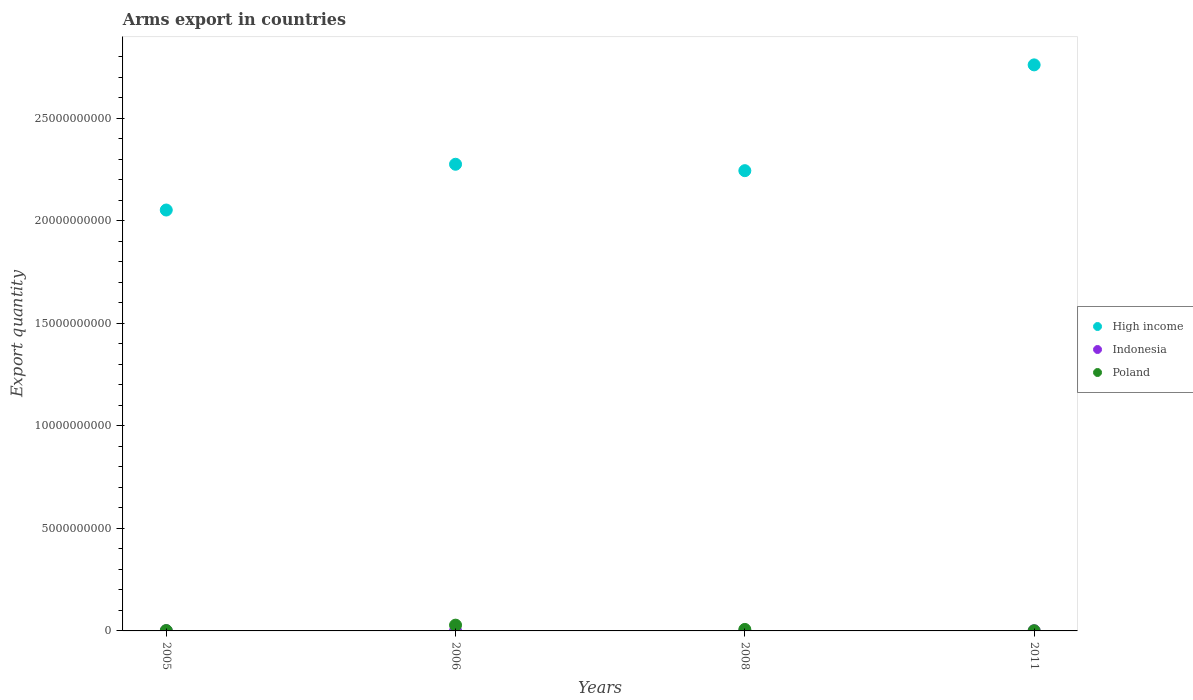Is the number of dotlines equal to the number of legend labels?
Keep it short and to the point. Yes. What is the total arms export in Poland in 2008?
Your response must be concise. 7.30e+07. Across all years, what is the maximum total arms export in Poland?
Offer a very short reply. 2.82e+08. In which year was the total arms export in High income maximum?
Make the answer very short. 2011. What is the total total arms export in Poland in the graph?
Keep it short and to the point. 3.81e+08. What is the difference between the total arms export in Poland in 2005 and that in 2006?
Your response must be concise. -2.64e+08. What is the difference between the total arms export in High income in 2006 and the total arms export in Poland in 2005?
Provide a short and direct response. 2.27e+1. What is the average total arms export in High income per year?
Provide a short and direct response. 2.33e+1. In the year 2006, what is the difference between the total arms export in High income and total arms export in Indonesia?
Offer a terse response. 2.28e+1. In how many years, is the total arms export in High income greater than 8000000000?
Offer a terse response. 4. What is the ratio of the total arms export in High income in 2008 to that in 2011?
Keep it short and to the point. 0.81. Is the total arms export in Indonesia in 2005 less than that in 2011?
Give a very brief answer. No. Is the difference between the total arms export in High income in 2008 and 2011 greater than the difference between the total arms export in Indonesia in 2008 and 2011?
Your answer should be compact. No. What is the difference between the highest and the second highest total arms export in Indonesia?
Provide a succinct answer. 0. What is the difference between the highest and the lowest total arms export in High income?
Your answer should be compact. 7.08e+09. In how many years, is the total arms export in High income greater than the average total arms export in High income taken over all years?
Offer a very short reply. 1. Is the sum of the total arms export in High income in 2005 and 2011 greater than the maximum total arms export in Poland across all years?
Offer a very short reply. Yes. How many years are there in the graph?
Keep it short and to the point. 4. Does the graph contain any zero values?
Ensure brevity in your answer.  No. Where does the legend appear in the graph?
Provide a short and direct response. Center right. How many legend labels are there?
Provide a short and direct response. 3. How are the legend labels stacked?
Your response must be concise. Vertical. What is the title of the graph?
Offer a terse response. Arms export in countries. What is the label or title of the Y-axis?
Offer a very short reply. Export quantity. What is the Export quantity of High income in 2005?
Keep it short and to the point. 2.05e+1. What is the Export quantity of Poland in 2005?
Your answer should be very brief. 1.80e+07. What is the Export quantity in High income in 2006?
Provide a succinct answer. 2.28e+1. What is the Export quantity in Indonesia in 2006?
Make the answer very short. 8.00e+06. What is the Export quantity of Poland in 2006?
Keep it short and to the point. 2.82e+08. What is the Export quantity of High income in 2008?
Your response must be concise. 2.25e+1. What is the Export quantity of Poland in 2008?
Give a very brief answer. 7.30e+07. What is the Export quantity of High income in 2011?
Your answer should be compact. 2.76e+1. Across all years, what is the maximum Export quantity in High income?
Offer a very short reply. 2.76e+1. Across all years, what is the maximum Export quantity in Poland?
Offer a terse response. 2.82e+08. Across all years, what is the minimum Export quantity in High income?
Keep it short and to the point. 2.05e+1. What is the total Export quantity of High income in the graph?
Provide a succinct answer. 9.34e+1. What is the total Export quantity in Indonesia in the graph?
Offer a very short reply. 2.50e+07. What is the total Export quantity of Poland in the graph?
Your response must be concise. 3.81e+08. What is the difference between the Export quantity in High income in 2005 and that in 2006?
Make the answer very short. -2.23e+09. What is the difference between the Export quantity in Poland in 2005 and that in 2006?
Keep it short and to the point. -2.64e+08. What is the difference between the Export quantity in High income in 2005 and that in 2008?
Offer a terse response. -1.92e+09. What is the difference between the Export quantity in Indonesia in 2005 and that in 2008?
Keep it short and to the point. 7.00e+06. What is the difference between the Export quantity of Poland in 2005 and that in 2008?
Give a very brief answer. -5.50e+07. What is the difference between the Export quantity of High income in 2005 and that in 2011?
Your response must be concise. -7.08e+09. What is the difference between the Export quantity in High income in 2006 and that in 2008?
Ensure brevity in your answer.  3.13e+08. What is the difference between the Export quantity of Indonesia in 2006 and that in 2008?
Your response must be concise. 7.00e+06. What is the difference between the Export quantity in Poland in 2006 and that in 2008?
Your response must be concise. 2.09e+08. What is the difference between the Export quantity in High income in 2006 and that in 2011?
Offer a very short reply. -4.85e+09. What is the difference between the Export quantity in Poland in 2006 and that in 2011?
Offer a terse response. 2.74e+08. What is the difference between the Export quantity of High income in 2008 and that in 2011?
Your answer should be compact. -5.16e+09. What is the difference between the Export quantity in Indonesia in 2008 and that in 2011?
Offer a very short reply. -7.00e+06. What is the difference between the Export quantity in Poland in 2008 and that in 2011?
Provide a short and direct response. 6.50e+07. What is the difference between the Export quantity in High income in 2005 and the Export quantity in Indonesia in 2006?
Provide a short and direct response. 2.05e+1. What is the difference between the Export quantity of High income in 2005 and the Export quantity of Poland in 2006?
Offer a very short reply. 2.03e+1. What is the difference between the Export quantity in Indonesia in 2005 and the Export quantity in Poland in 2006?
Keep it short and to the point. -2.74e+08. What is the difference between the Export quantity of High income in 2005 and the Export quantity of Indonesia in 2008?
Ensure brevity in your answer.  2.05e+1. What is the difference between the Export quantity in High income in 2005 and the Export quantity in Poland in 2008?
Give a very brief answer. 2.05e+1. What is the difference between the Export quantity of Indonesia in 2005 and the Export quantity of Poland in 2008?
Your answer should be very brief. -6.50e+07. What is the difference between the Export quantity in High income in 2005 and the Export quantity in Indonesia in 2011?
Your answer should be very brief. 2.05e+1. What is the difference between the Export quantity of High income in 2005 and the Export quantity of Poland in 2011?
Offer a very short reply. 2.05e+1. What is the difference between the Export quantity in High income in 2006 and the Export quantity in Indonesia in 2008?
Ensure brevity in your answer.  2.28e+1. What is the difference between the Export quantity in High income in 2006 and the Export quantity in Poland in 2008?
Your response must be concise. 2.27e+1. What is the difference between the Export quantity in Indonesia in 2006 and the Export quantity in Poland in 2008?
Provide a short and direct response. -6.50e+07. What is the difference between the Export quantity in High income in 2006 and the Export quantity in Indonesia in 2011?
Your response must be concise. 2.28e+1. What is the difference between the Export quantity of High income in 2006 and the Export quantity of Poland in 2011?
Keep it short and to the point. 2.28e+1. What is the difference between the Export quantity of Indonesia in 2006 and the Export quantity of Poland in 2011?
Your answer should be very brief. 0. What is the difference between the Export quantity of High income in 2008 and the Export quantity of Indonesia in 2011?
Your answer should be compact. 2.24e+1. What is the difference between the Export quantity of High income in 2008 and the Export quantity of Poland in 2011?
Keep it short and to the point. 2.24e+1. What is the difference between the Export quantity in Indonesia in 2008 and the Export quantity in Poland in 2011?
Provide a succinct answer. -7.00e+06. What is the average Export quantity in High income per year?
Keep it short and to the point. 2.33e+1. What is the average Export quantity in Indonesia per year?
Offer a terse response. 6.25e+06. What is the average Export quantity in Poland per year?
Keep it short and to the point. 9.52e+07. In the year 2005, what is the difference between the Export quantity in High income and Export quantity in Indonesia?
Keep it short and to the point. 2.05e+1. In the year 2005, what is the difference between the Export quantity in High income and Export quantity in Poland?
Your answer should be very brief. 2.05e+1. In the year 2005, what is the difference between the Export quantity in Indonesia and Export quantity in Poland?
Give a very brief answer. -1.00e+07. In the year 2006, what is the difference between the Export quantity in High income and Export quantity in Indonesia?
Your answer should be compact. 2.28e+1. In the year 2006, what is the difference between the Export quantity in High income and Export quantity in Poland?
Your answer should be compact. 2.25e+1. In the year 2006, what is the difference between the Export quantity in Indonesia and Export quantity in Poland?
Offer a terse response. -2.74e+08. In the year 2008, what is the difference between the Export quantity of High income and Export quantity of Indonesia?
Your answer should be very brief. 2.25e+1. In the year 2008, what is the difference between the Export quantity of High income and Export quantity of Poland?
Provide a succinct answer. 2.24e+1. In the year 2008, what is the difference between the Export quantity of Indonesia and Export quantity of Poland?
Your response must be concise. -7.20e+07. In the year 2011, what is the difference between the Export quantity in High income and Export quantity in Indonesia?
Ensure brevity in your answer.  2.76e+1. In the year 2011, what is the difference between the Export quantity in High income and Export quantity in Poland?
Give a very brief answer. 2.76e+1. What is the ratio of the Export quantity in High income in 2005 to that in 2006?
Offer a very short reply. 0.9. What is the ratio of the Export quantity in Poland in 2005 to that in 2006?
Provide a short and direct response. 0.06. What is the ratio of the Export quantity in High income in 2005 to that in 2008?
Offer a terse response. 0.91. What is the ratio of the Export quantity in Poland in 2005 to that in 2008?
Ensure brevity in your answer.  0.25. What is the ratio of the Export quantity in High income in 2005 to that in 2011?
Give a very brief answer. 0.74. What is the ratio of the Export quantity in Indonesia in 2005 to that in 2011?
Make the answer very short. 1. What is the ratio of the Export quantity of Poland in 2005 to that in 2011?
Your answer should be very brief. 2.25. What is the ratio of the Export quantity of High income in 2006 to that in 2008?
Offer a terse response. 1.01. What is the ratio of the Export quantity in Indonesia in 2006 to that in 2008?
Keep it short and to the point. 8. What is the ratio of the Export quantity of Poland in 2006 to that in 2008?
Provide a short and direct response. 3.86. What is the ratio of the Export quantity of High income in 2006 to that in 2011?
Keep it short and to the point. 0.82. What is the ratio of the Export quantity in Indonesia in 2006 to that in 2011?
Your answer should be very brief. 1. What is the ratio of the Export quantity in Poland in 2006 to that in 2011?
Offer a terse response. 35.25. What is the ratio of the Export quantity in High income in 2008 to that in 2011?
Offer a terse response. 0.81. What is the ratio of the Export quantity of Poland in 2008 to that in 2011?
Keep it short and to the point. 9.12. What is the difference between the highest and the second highest Export quantity in High income?
Keep it short and to the point. 4.85e+09. What is the difference between the highest and the second highest Export quantity in Poland?
Give a very brief answer. 2.09e+08. What is the difference between the highest and the lowest Export quantity in High income?
Offer a very short reply. 7.08e+09. What is the difference between the highest and the lowest Export quantity in Indonesia?
Offer a terse response. 7.00e+06. What is the difference between the highest and the lowest Export quantity in Poland?
Your answer should be compact. 2.74e+08. 